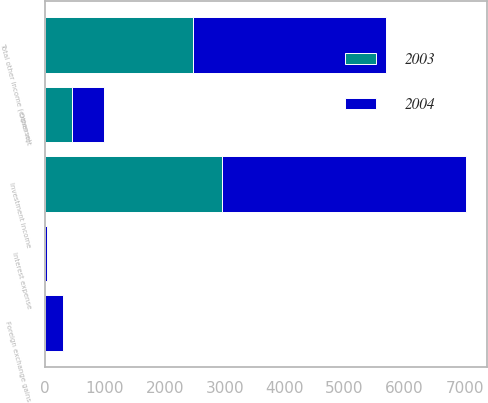Convert chart. <chart><loc_0><loc_0><loc_500><loc_500><stacked_bar_chart><ecel><fcel>Investment income<fcel>Interest expense<fcel>Foreign exchange gains<fcel>Other net<fcel>Total other income (expense)<nl><fcel>2003<fcel>2949<fcel>5<fcel>9<fcel>457<fcel>2478<nl><fcel>2004<fcel>4079<fcel>38<fcel>304<fcel>524<fcel>3213<nl></chart> 